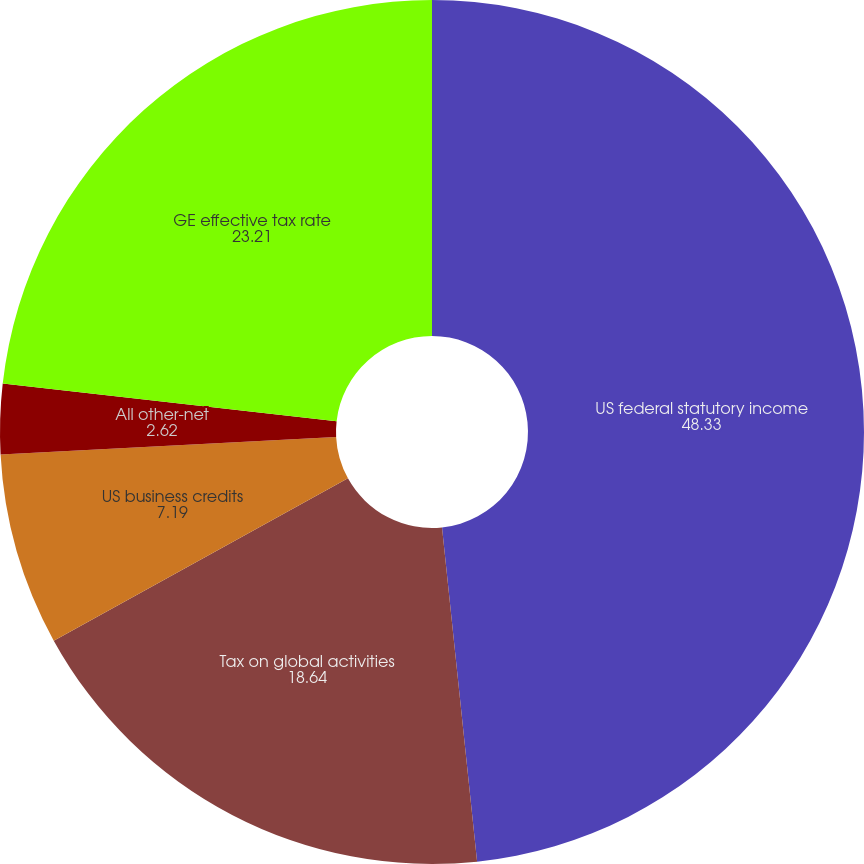<chart> <loc_0><loc_0><loc_500><loc_500><pie_chart><fcel>US federal statutory income<fcel>Tax on global activities<fcel>US business credits<fcel>All other-net<fcel>GE effective tax rate<nl><fcel>48.33%<fcel>18.64%<fcel>7.19%<fcel>2.62%<fcel>23.21%<nl></chart> 